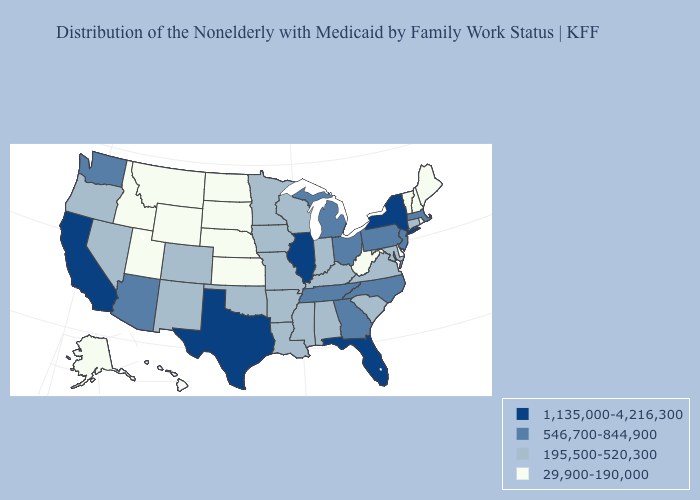What is the lowest value in the USA?
Answer briefly. 29,900-190,000. What is the value of Montana?
Answer briefly. 29,900-190,000. Does West Virginia have the lowest value in the South?
Answer briefly. Yes. What is the value of West Virginia?
Keep it brief. 29,900-190,000. Which states have the lowest value in the USA?
Be succinct. Alaska, Delaware, Hawaii, Idaho, Kansas, Maine, Montana, Nebraska, New Hampshire, North Dakota, Rhode Island, South Dakota, Utah, Vermont, West Virginia, Wyoming. How many symbols are there in the legend?
Concise answer only. 4. What is the value of Colorado?
Keep it brief. 195,500-520,300. What is the highest value in the MidWest ?
Short answer required. 1,135,000-4,216,300. Does West Virginia have a higher value than Texas?
Write a very short answer. No. Does Connecticut have a lower value than Massachusetts?
Short answer required. Yes. What is the value of Nevada?
Write a very short answer. 195,500-520,300. Among the states that border Iowa , does Minnesota have the lowest value?
Quick response, please. No. Name the states that have a value in the range 195,500-520,300?
Answer briefly. Alabama, Arkansas, Colorado, Connecticut, Indiana, Iowa, Kentucky, Louisiana, Maryland, Minnesota, Mississippi, Missouri, Nevada, New Mexico, Oklahoma, Oregon, South Carolina, Virginia, Wisconsin. What is the highest value in the West ?
Write a very short answer. 1,135,000-4,216,300. Among the states that border Delaware , which have the lowest value?
Concise answer only. Maryland. 